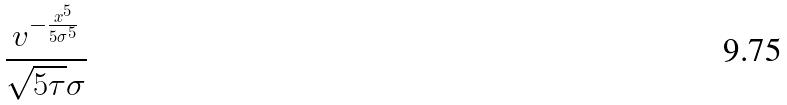<formula> <loc_0><loc_0><loc_500><loc_500>\frac { v ^ { - \frac { x ^ { 5 } } { 5 \sigma ^ { 5 } } } } { \sqrt { 5 \tau } \sigma }</formula> 